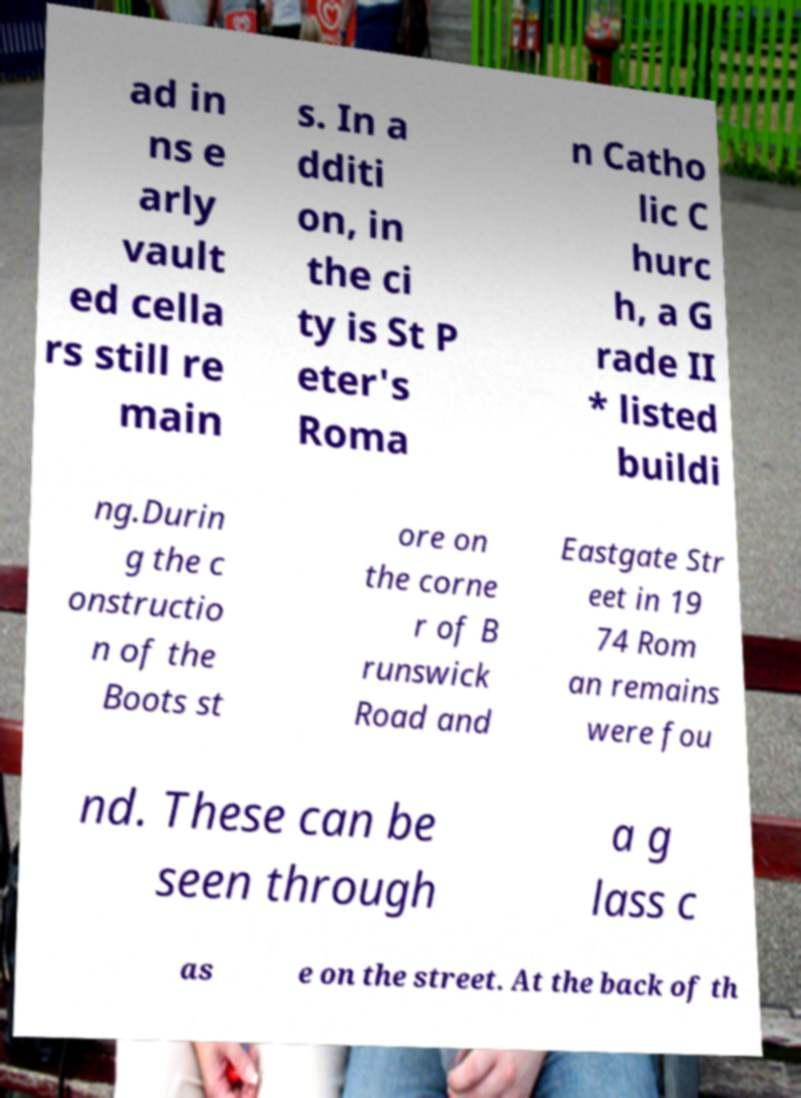I need the written content from this picture converted into text. Can you do that? ad in ns e arly vault ed cella rs still re main s. In a dditi on, in the ci ty is St P eter's Roma n Catho lic C hurc h, a G rade II * listed buildi ng.Durin g the c onstructio n of the Boots st ore on the corne r of B runswick Road and Eastgate Str eet in 19 74 Rom an remains were fou nd. These can be seen through a g lass c as e on the street. At the back of th 